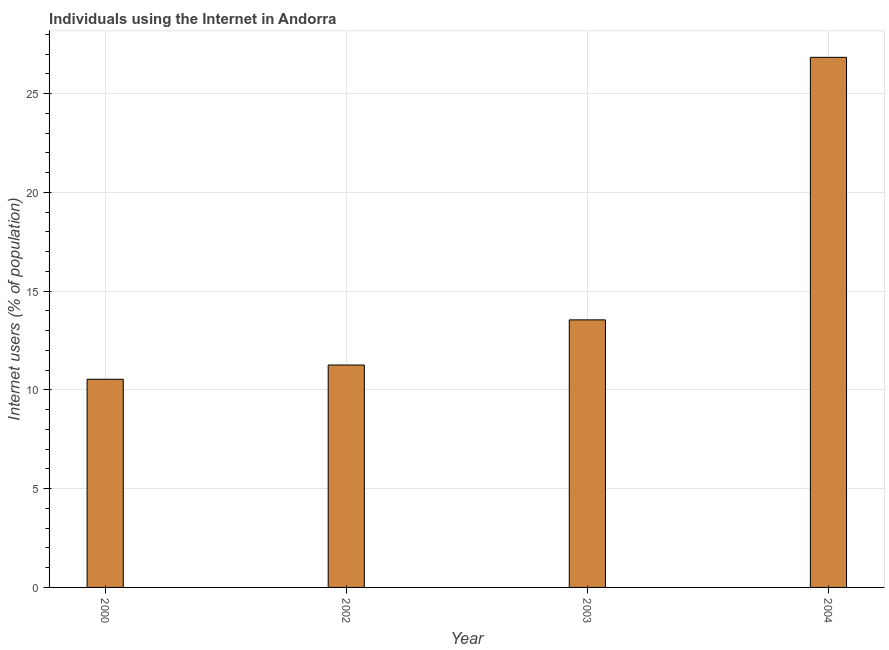Does the graph contain any zero values?
Provide a succinct answer. No. Does the graph contain grids?
Keep it short and to the point. Yes. What is the title of the graph?
Offer a terse response. Individuals using the Internet in Andorra. What is the label or title of the Y-axis?
Ensure brevity in your answer.  Internet users (% of population). What is the number of internet users in 2002?
Your answer should be compact. 11.26. Across all years, what is the maximum number of internet users?
Make the answer very short. 26.84. Across all years, what is the minimum number of internet users?
Give a very brief answer. 10.54. What is the sum of the number of internet users?
Offer a terse response. 62.18. What is the difference between the number of internet users in 2000 and 2002?
Provide a succinct answer. -0.72. What is the average number of internet users per year?
Offer a terse response. 15.55. What is the median number of internet users?
Make the answer very short. 12.4. Do a majority of the years between 2002 and 2004 (inclusive) have number of internet users greater than 26 %?
Offer a terse response. No. What is the ratio of the number of internet users in 2000 to that in 2003?
Your response must be concise. 0.78. What is the difference between the highest and the second highest number of internet users?
Ensure brevity in your answer.  13.29. What is the difference between the highest and the lowest number of internet users?
Your response must be concise. 16.3. In how many years, is the number of internet users greater than the average number of internet users taken over all years?
Keep it short and to the point. 1. What is the Internet users (% of population) in 2000?
Ensure brevity in your answer.  10.54. What is the Internet users (% of population) in 2002?
Make the answer very short. 11.26. What is the Internet users (% of population) of 2003?
Offer a terse response. 13.55. What is the Internet users (% of population) of 2004?
Your answer should be compact. 26.84. What is the difference between the Internet users (% of population) in 2000 and 2002?
Provide a succinct answer. -0.72. What is the difference between the Internet users (% of population) in 2000 and 2003?
Your answer should be very brief. -3.01. What is the difference between the Internet users (% of population) in 2000 and 2004?
Keep it short and to the point. -16.3. What is the difference between the Internet users (% of population) in 2002 and 2003?
Your response must be concise. -2.29. What is the difference between the Internet users (% of population) in 2002 and 2004?
Offer a very short reply. -15.58. What is the difference between the Internet users (% of population) in 2003 and 2004?
Make the answer very short. -13.29. What is the ratio of the Internet users (% of population) in 2000 to that in 2002?
Give a very brief answer. 0.94. What is the ratio of the Internet users (% of population) in 2000 to that in 2003?
Offer a terse response. 0.78. What is the ratio of the Internet users (% of population) in 2000 to that in 2004?
Keep it short and to the point. 0.39. What is the ratio of the Internet users (% of population) in 2002 to that in 2003?
Give a very brief answer. 0.83. What is the ratio of the Internet users (% of population) in 2002 to that in 2004?
Ensure brevity in your answer.  0.42. What is the ratio of the Internet users (% of population) in 2003 to that in 2004?
Your response must be concise. 0.51. 